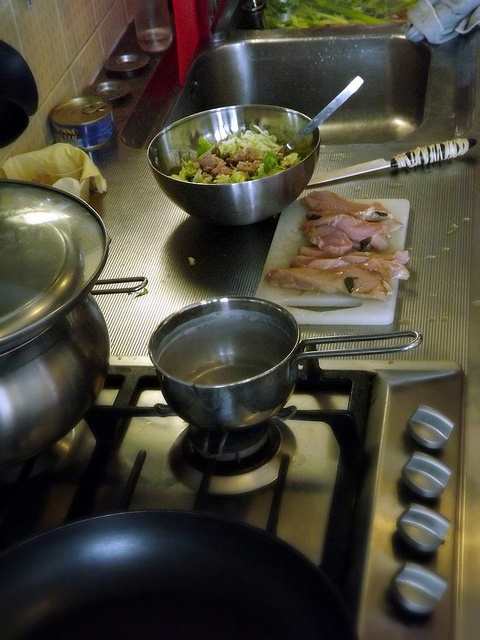Describe the objects in this image and their specific colors. I can see oven in gray, black, darkgreen, and olive tones, sink in gray, black, darkgreen, and purple tones, bowl in gray, black, and olive tones, knife in gray, darkgray, black, and tan tones, and cup in gray, black, and maroon tones in this image. 